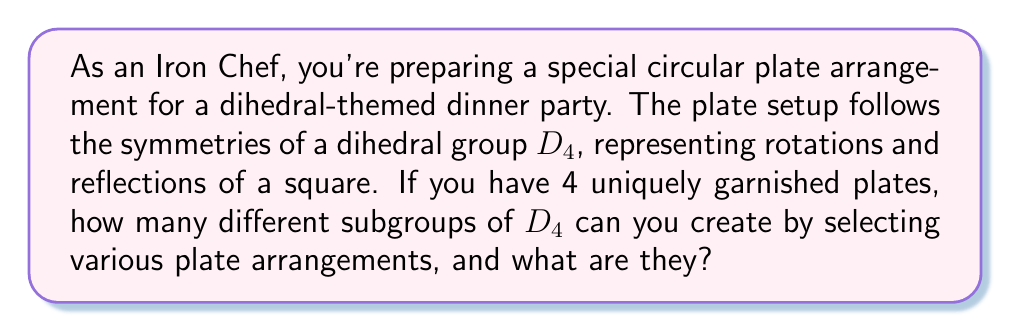Teach me how to tackle this problem. Let's approach this step-by-step:

1) First, recall that the dihedral group $D_4$ has 8 elements:
   - 4 rotations: $e$ (identity), $r$ (90° clockwise), $r^2$ (180°), $r^3$ (270° clockwise)
   - 4 reflections: $s$ (vertical), $sr$ (diagonal), $sr^2$ (horizontal), $sr^3$ (other diagonal)

2) To find subgroups, we need to identify sets of elements that form a group under the operation of $D_4$.

3) The trivial subgroups are always present:
   - $\{e\}$ (identity subgroup)
   - $D_4$ itself (the entire group)

4) Cyclic subgroups generated by each element:
   - $\langle r \rangle = \{e, r, r^2, r^3\}$ (order 4)
   - $\langle r^2 \rangle = \{e, r^2\}$ (order 2)
   - $\langle s \rangle = \{e, s\}$ (order 2)
   - $\langle sr \rangle = \{e, sr\}$ (order 2)
   - $\langle sr^2 \rangle = \{e, sr^2\}$ (order 2)
   - $\langle sr^3 \rangle = \{e, sr^3\}$ (order 2)

5) There's one more subgroup of order 4:
   - $\{e, r^2, s, sr^2\}$ (Klein four-group)

6) In total, we have:
   - 1 subgroup of order 1
   - 5 subgroups of order 2
   - 2 subgroups of order 4
   - 1 subgroup of order 8 (the entire group)

Therefore, there are 9 different subgroups in total.
Answer: The dihedral group $D_4$ has 9 subgroups:
$$\{e\}, \{e,r^2\}, \{e,s\}, \{e,sr\}, \{e,sr^2\}, \{e,sr^3\}, \{e,r,r^2,r^3\}, \{e,r^2,s,sr^2\}, D_4$$ 